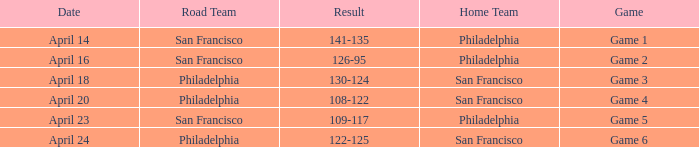What was the result of the April 16 game? 126-95. 